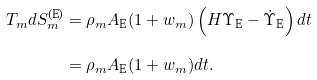Convert formula to latex. <formula><loc_0><loc_0><loc_500><loc_500>T _ { m } d S _ { m } ^ { \text {(E)} } & = \rho _ { m } A _ { \text {E} } ( 1 + w _ { m } ) \left ( H \Upsilon _ { \text {E} } - \dot { \Upsilon } _ { \text {E} } \right ) d t \\ & = \rho _ { m } A _ { \text {E} } ( 1 + w _ { m } ) d t .</formula> 